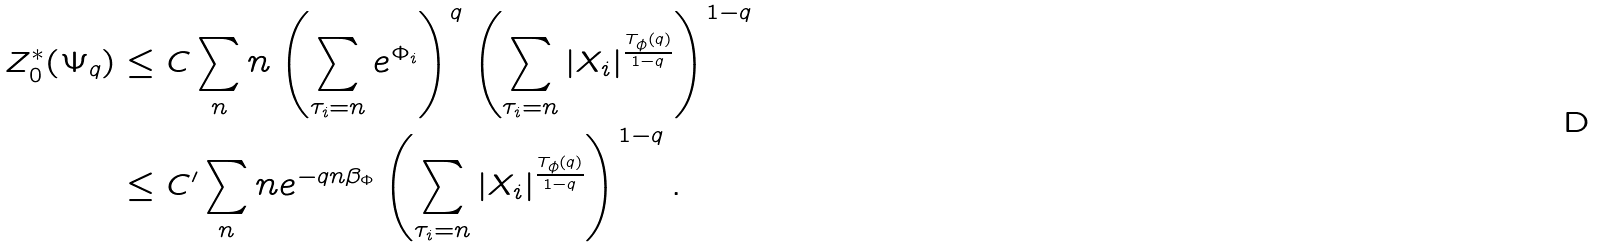<formula> <loc_0><loc_0><loc_500><loc_500>Z _ { 0 } ^ { * } ( \Psi _ { q } ) & \leq C \sum _ { n } n \left ( \sum _ { \tau _ { i } = n } e ^ { \Phi _ { i } } \right ) ^ { q } \left ( \sum _ { \tau _ { i } = n } | X _ { i } | ^ { \frac { T _ { \phi } ( q ) } { 1 - q } } \right ) ^ { 1 - q } \\ & \leq C ^ { \prime } \sum _ { n } n e ^ { - q n \beta _ { \Phi } } \left ( \sum _ { \tau _ { i } = n } | X _ { i } | ^ { \frac { T _ { \phi } ( q ) } { 1 - q } } \right ) ^ { 1 - q } .</formula> 